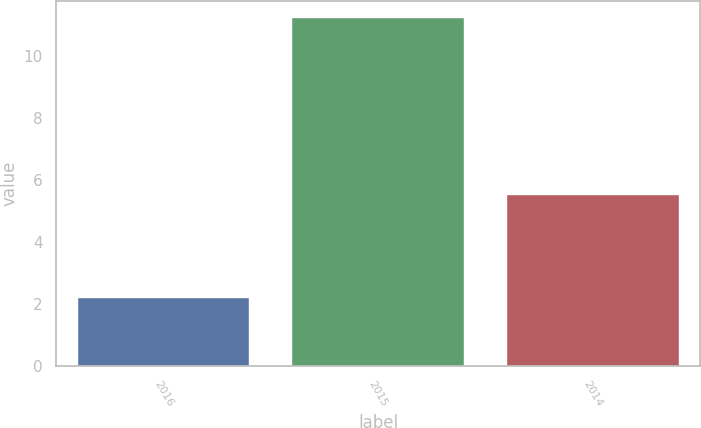<chart> <loc_0><loc_0><loc_500><loc_500><bar_chart><fcel>2016<fcel>2015<fcel>2014<nl><fcel>2.2<fcel>11.2<fcel>5.5<nl></chart> 